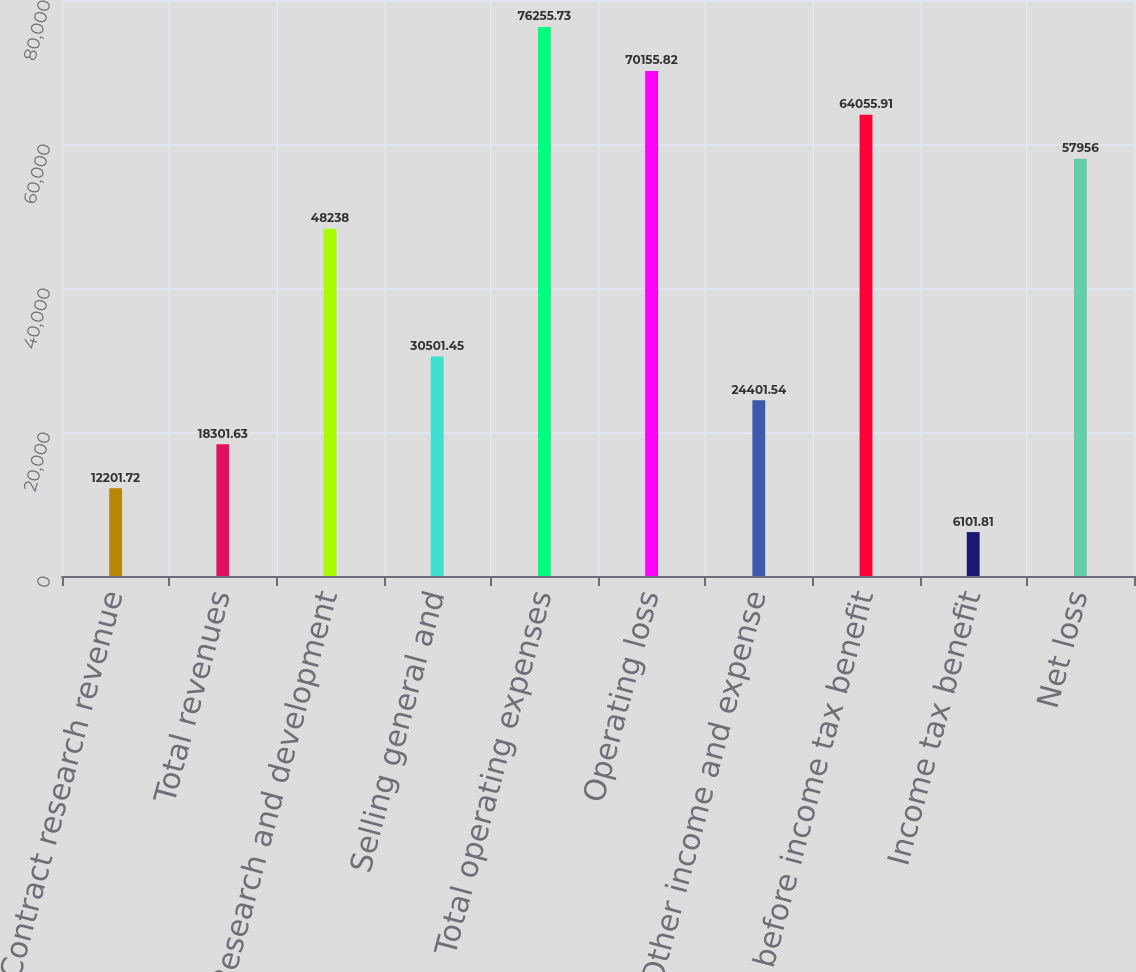Convert chart. <chart><loc_0><loc_0><loc_500><loc_500><bar_chart><fcel>Contract research revenue<fcel>Total revenues<fcel>Research and development<fcel>Selling general and<fcel>Total operating expenses<fcel>Operating loss<fcel>Other income and expense<fcel>Loss before income tax benefit<fcel>Income tax benefit<fcel>Net loss<nl><fcel>12201.7<fcel>18301.6<fcel>48238<fcel>30501.5<fcel>76255.7<fcel>70155.8<fcel>24401.5<fcel>64055.9<fcel>6101.81<fcel>57956<nl></chart> 